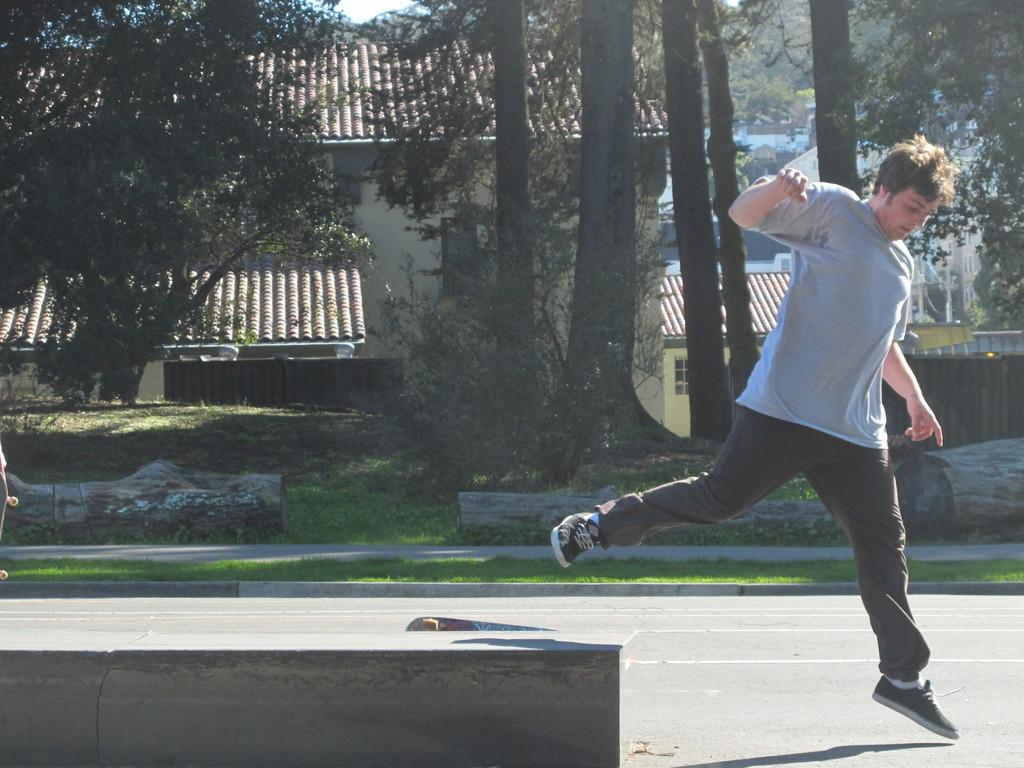Who or what is present in the image? There is a person in the image. What is the person wearing? The person is wearing clothes and shoes. What object is associated with the person in the image? There is a skateboard in the image. What type of surface can be seen in the image? There is a road in the image. What type of vegetation is present in the image? There is grass and trees in the image. What type of structure is visible in the image? There is a building in the image. What part of the natural environment is visible in the image? The sky is visible in the image. What type of collar can be seen on the person's cap in the image? There is no cap or collar present in the image. 